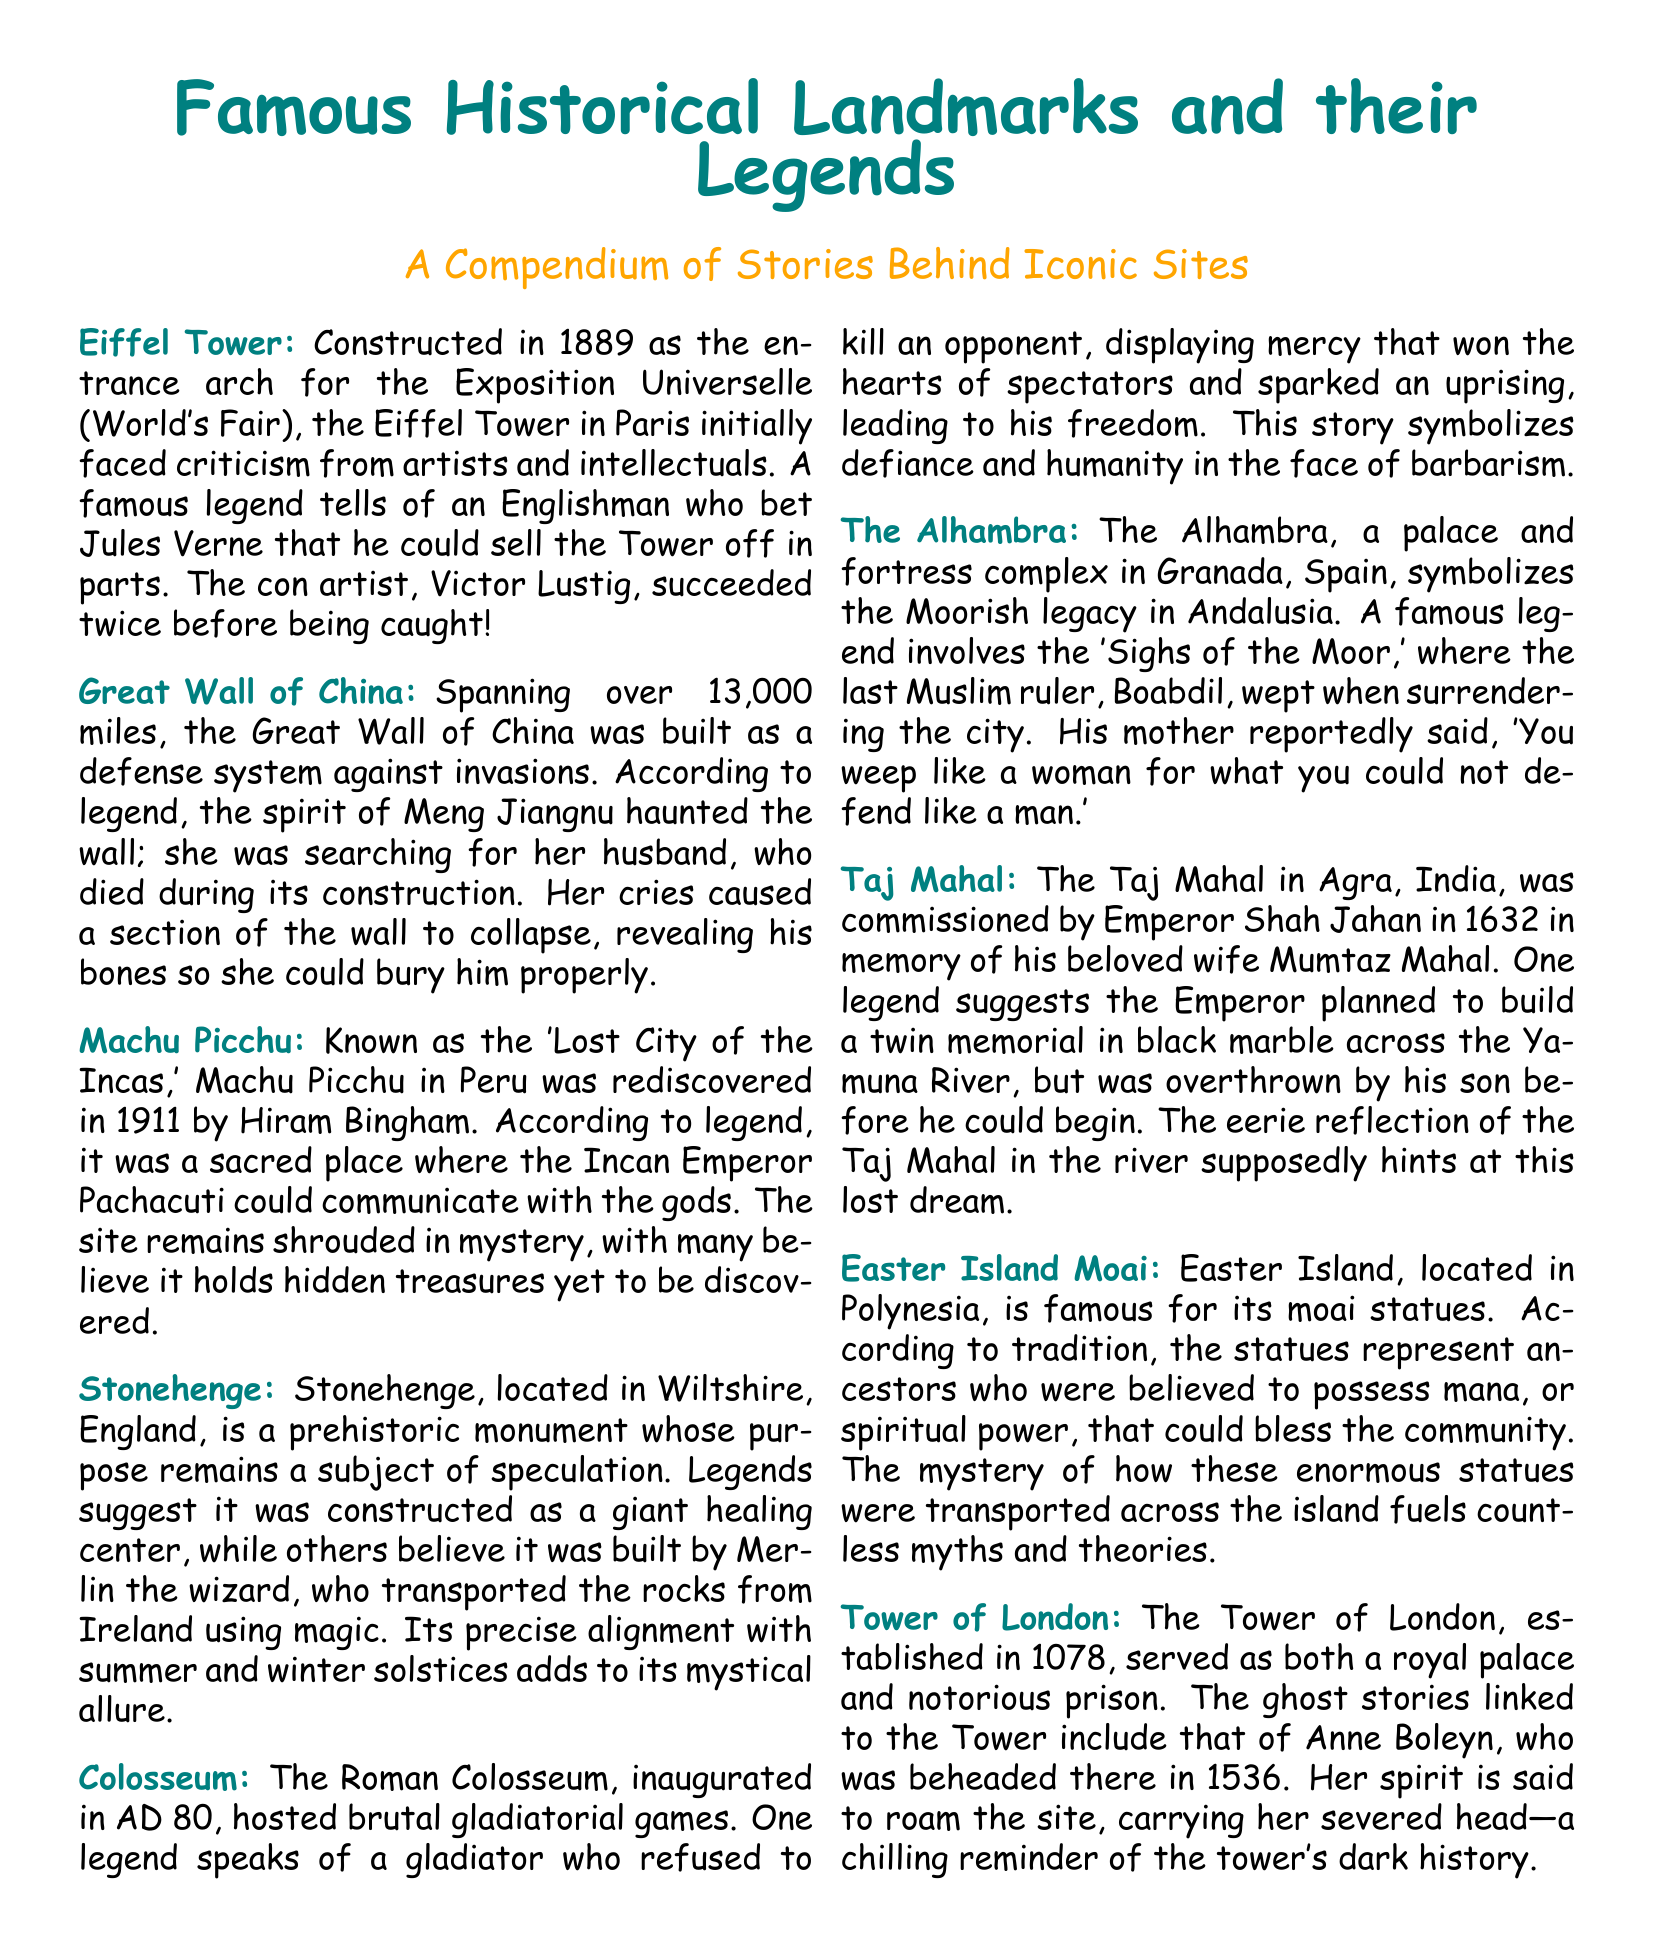what year was the Eiffel Tower constructed? The year mentioned for the construction of the Eiffel Tower is 1889.
Answer: 1889 what is the legend associated with the Great Wall of China? The legend involves the spirit of Meng Jiangnu, who haunted the wall searching for her deceased husband.
Answer: Meng Jiangnu which emperor commissioned the Taj Mahal? The document states that the Taj Mahal was commissioned by Emperor Shah Jahan.
Answer: Shah Jahan how long is the Great Wall of China? The document specifies that the Great Wall of China spans over 13,000 miles.
Answer: 13,000 miles what happened to the last Muslim ruler of Granada according to legend? The legend recounts that Boabdil wept when surrendering the city of Granada.
Answer: Wept which historical landmark is referred to as the 'Lost City of the Incas'? Machu Picchu is identified as the 'Lost City of the Incas.'
Answer: Machu Picchu who wept at the Sighs of the Moor? According to the legend, the last Muslim ruler, Boabdil, wept at the Sighs of the Moor.
Answer: Boabdil which ancient structure is believed to have been constructed by Merlin? The document suggests that Stonehenge was constructed by Merlin the wizard.
Answer: Stonehenge what is the primary purpose of the Tower of London as mentioned? The Tower of London served as both a royal palace and a notorious prison.
Answer: Royal palace and prison 